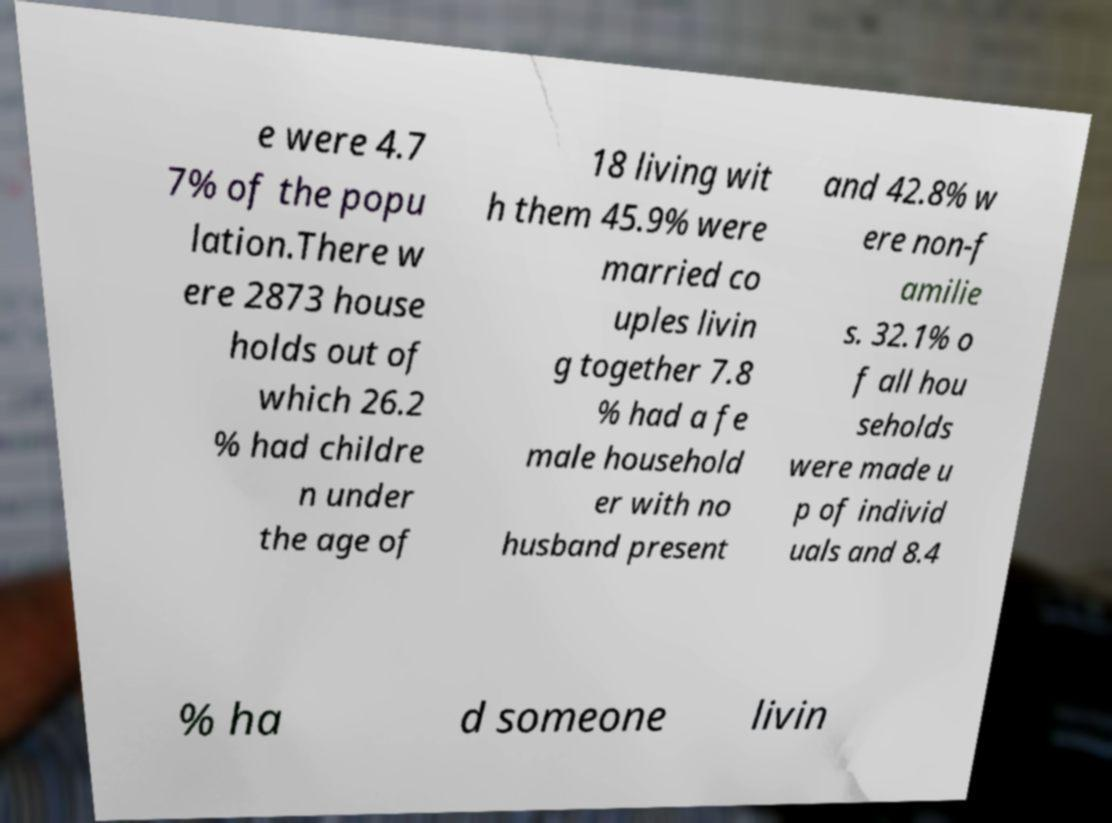There's text embedded in this image that I need extracted. Can you transcribe it verbatim? e were 4.7 7% of the popu lation.There w ere 2873 house holds out of which 26.2 % had childre n under the age of 18 living wit h them 45.9% were married co uples livin g together 7.8 % had a fe male household er with no husband present and 42.8% w ere non-f amilie s. 32.1% o f all hou seholds were made u p of individ uals and 8.4 % ha d someone livin 